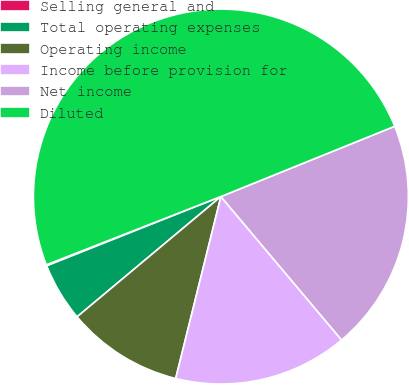<chart> <loc_0><loc_0><loc_500><loc_500><pie_chart><fcel>Selling general and<fcel>Total operating expenses<fcel>Operating income<fcel>Income before provision for<fcel>Net income<fcel>Diluted<nl><fcel>0.09%<fcel>5.06%<fcel>10.04%<fcel>15.01%<fcel>19.98%<fcel>49.82%<nl></chart> 